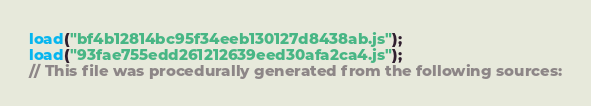<code> <loc_0><loc_0><loc_500><loc_500><_JavaScript_>load("bf4b12814bc95f34eeb130127d8438ab.js");
load("93fae755edd261212639eed30afa2ca4.js");
// This file was procedurally generated from the following sources:</code> 